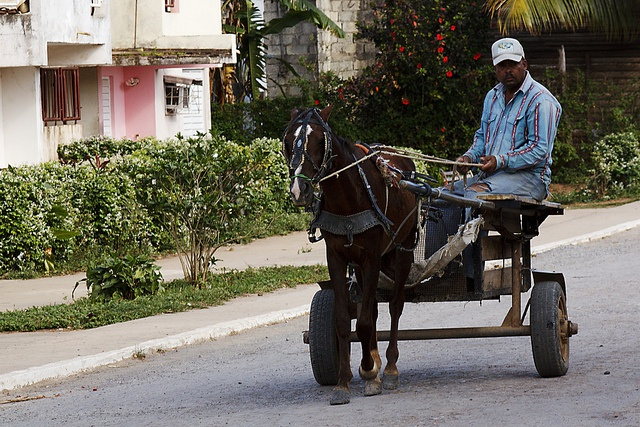Describe the objects in this image and their specific colors. I can see horse in beige, black, gray, maroon, and darkgray tones and people in beige, black, and gray tones in this image. 